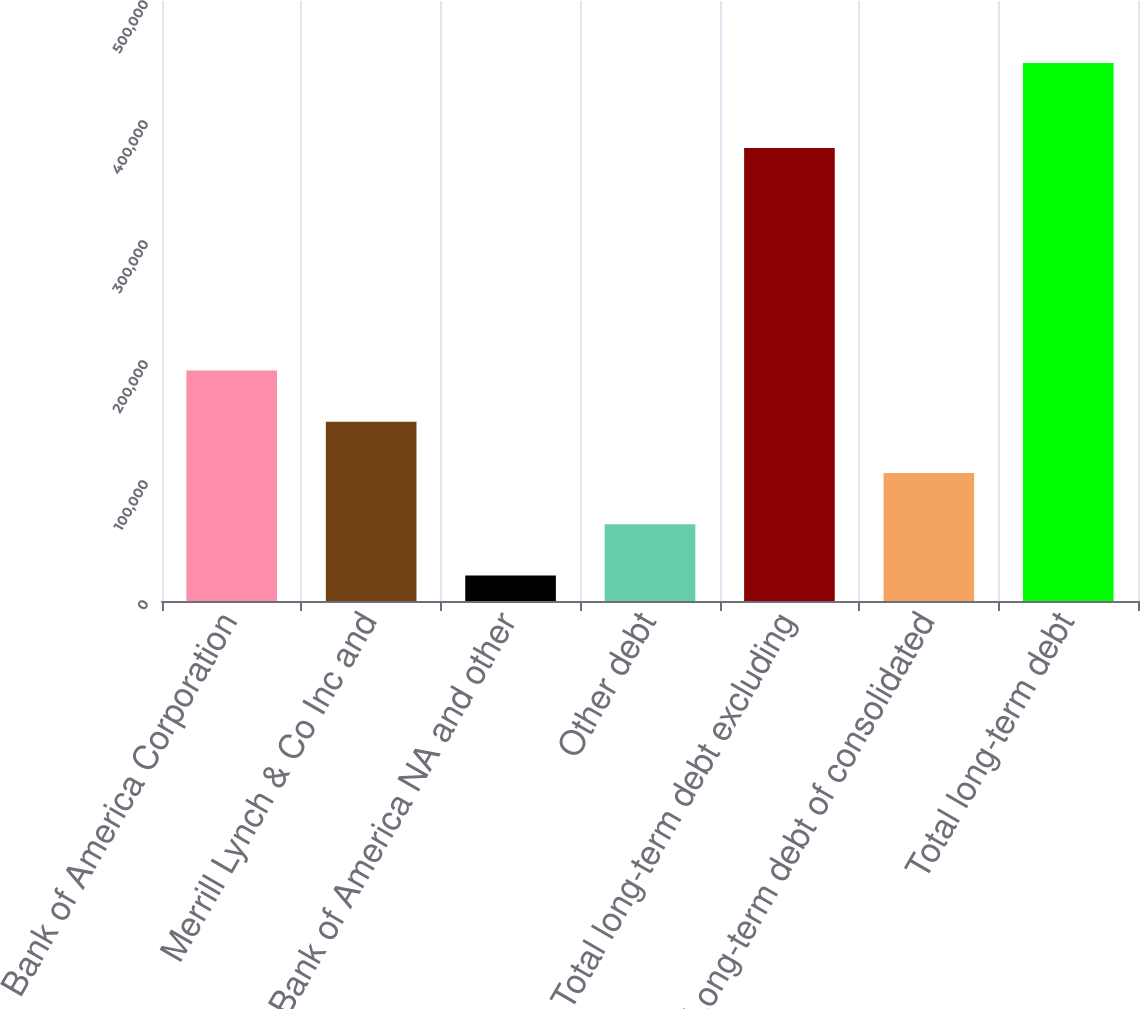Convert chart. <chart><loc_0><loc_0><loc_500><loc_500><bar_chart><fcel>Bank of America Corporation<fcel>Merrill Lynch & Co Inc and<fcel>Bank of America NA and other<fcel>Other debt<fcel>Total long-term debt excluding<fcel>Long-term debt of consolidated<fcel>Total long-term debt<nl><fcel>192133<fcel>149416<fcel>21267<fcel>63983.4<fcel>377418<fcel>106700<fcel>448431<nl></chart> 